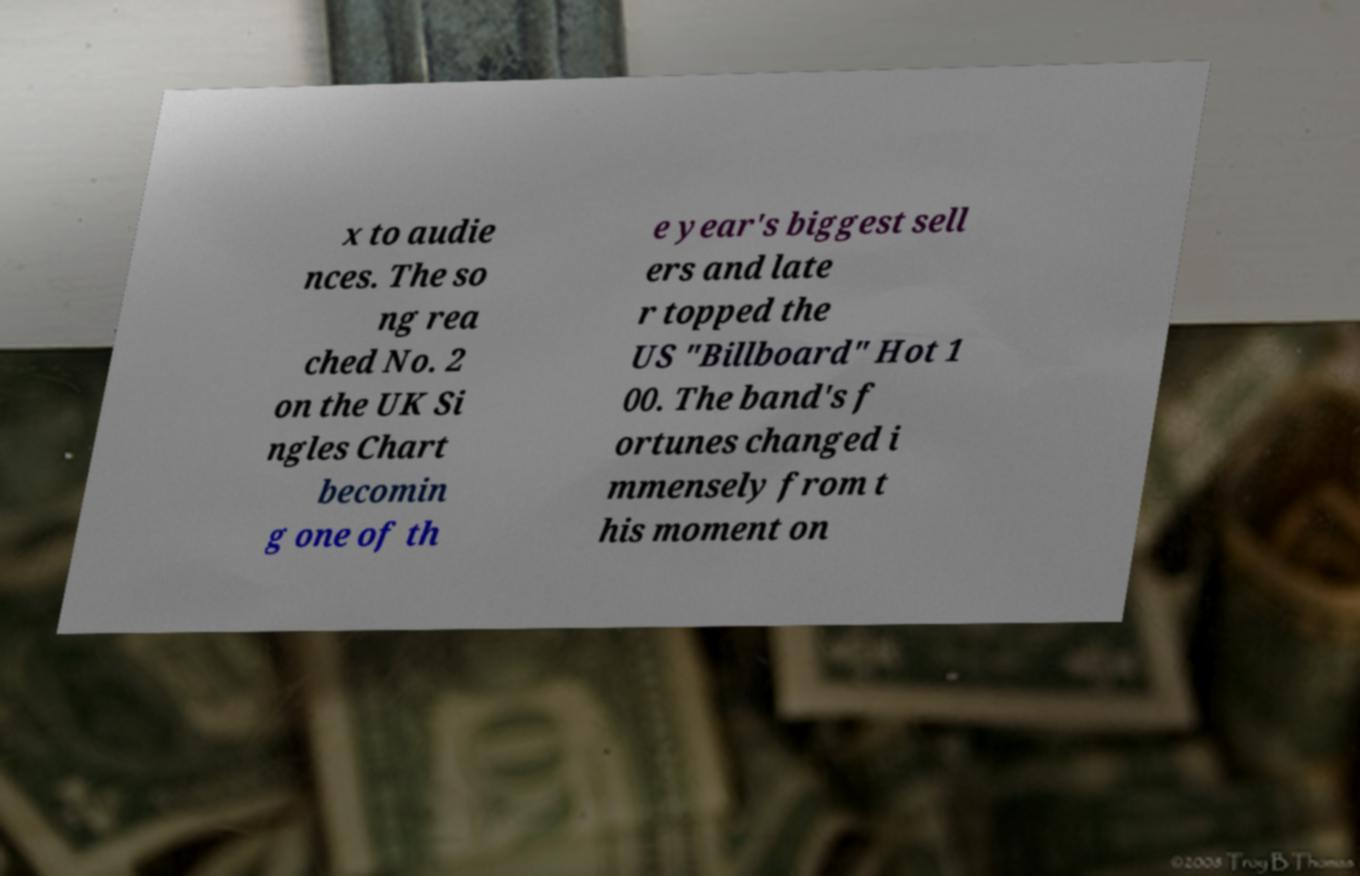Can you accurately transcribe the text from the provided image for me? x to audie nces. The so ng rea ched No. 2 on the UK Si ngles Chart becomin g one of th e year's biggest sell ers and late r topped the US "Billboard" Hot 1 00. The band's f ortunes changed i mmensely from t his moment on 